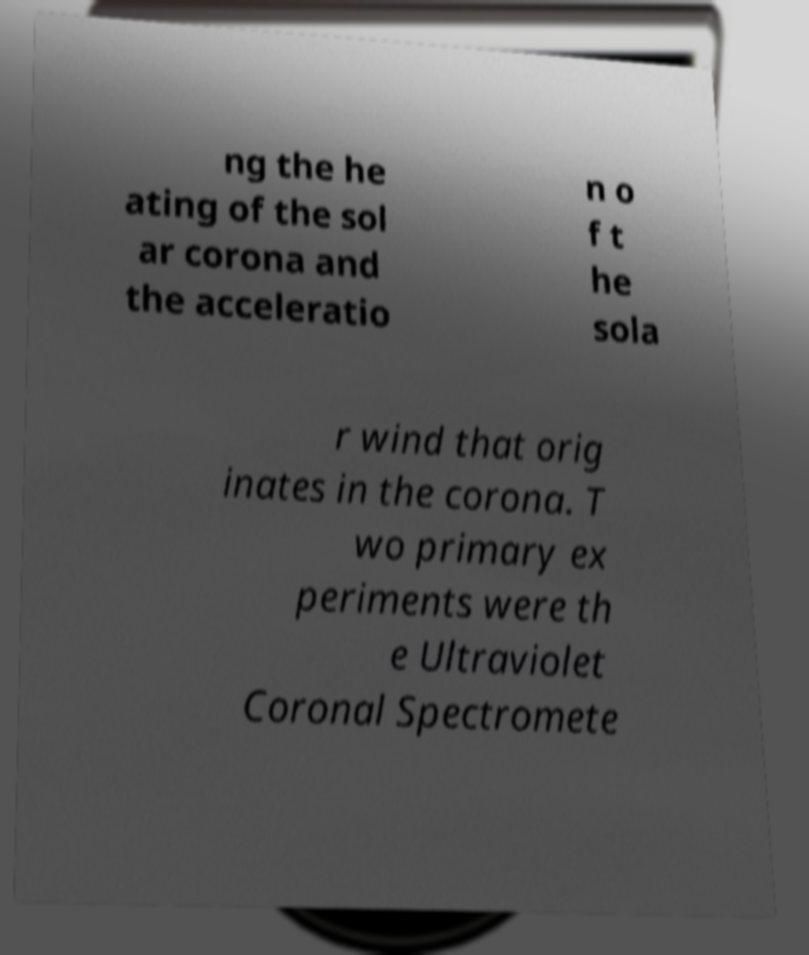Can you accurately transcribe the text from the provided image for me? ng the he ating of the sol ar corona and the acceleratio n o f t he sola r wind that orig inates in the corona. T wo primary ex periments were th e Ultraviolet Coronal Spectromete 